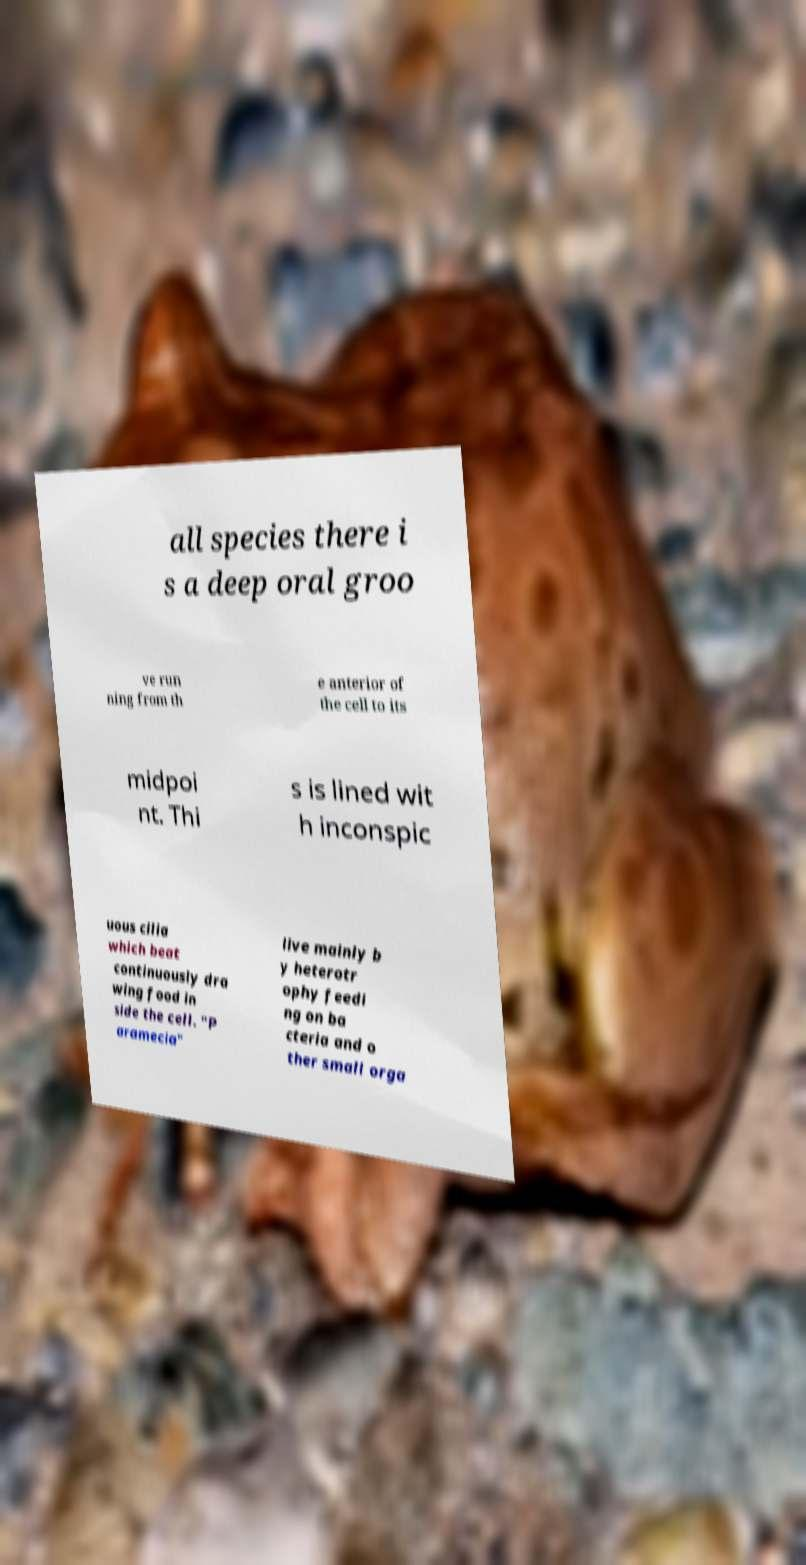There's text embedded in this image that I need extracted. Can you transcribe it verbatim? all species there i s a deep oral groo ve run ning from th e anterior of the cell to its midpoi nt. Thi s is lined wit h inconspic uous cilia which beat continuously dra wing food in side the cell. "P aramecia" live mainly b y heterotr ophy feedi ng on ba cteria and o ther small orga 